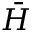<formula> <loc_0><loc_0><loc_500><loc_500>\bar { H }</formula> 